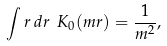Convert formula to latex. <formula><loc_0><loc_0><loc_500><loc_500>\int r \, d r \ K _ { 0 } ( m r ) = \frac { 1 } { m ^ { 2 } } ,</formula> 